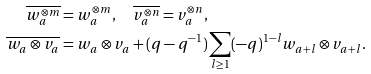<formula> <loc_0><loc_0><loc_500><loc_500>\overline { w _ { a } ^ { \otimes m } } & = w _ { a } ^ { \otimes m } , \quad \overline { v _ { a } ^ { \otimes n } } = v _ { a } ^ { \otimes n } , \\ \overline { w _ { a } \otimes v _ { a } } & = w _ { a } \otimes v _ { a } + ( q - q ^ { - 1 } ) \sum _ { l \geq 1 } ( - q ) ^ { 1 - l } w _ { a + l } \otimes v _ { a + l } .</formula> 